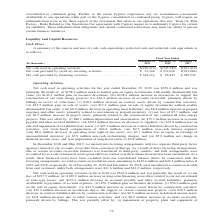From Sunpower Corporation's financial document, What are the components of the sources and uses of cash, cash equivalents, restricted cash and restricted cash equivalents? The document contains multiple relevant values: Operating activities, Investing activities, Financing activities. From the document: "Net cash used in operating activities . $(270,413) $(543,389) $(267,412) Net cash provided by (used in) investing activities. . $ 21,366 21,366 $ 274,..." Also, What was the net cash provided by investing activities in 2017? According to the financial document, (293,084). The relevant text states: "d in) investing activities. . $ 21,366 $ 274,900 $(293,084) Net cash provided by financing activities . $ 344,314 $ 85,847 $ 589,932..." Also, What was the reason for the title of certain accounts receivable balances being transferred to third-party vendors? Factoring arrangements with two separate third-party factor agencies related to our accounts receivable from customers in Europe. The document states: "In December 2018 and May 2019, we entered into factoring arrangements with two separate third-party factor agencies related to our accounts receivable..." Additionally, Which year was the net cash used in operating activities the highest? According to the financial document, 2018. The relevant text states: "(In thousands) December 29, 2019 December 30, 2018 December 31, 2017..." Also, can you calculate: What was the change in net cash provided by investing activities from 2018 to 2019? Based on the calculation: $21,366 - $274,900 , the result is -253534 (in thousands). This is based on the information: "h provided by (used in) investing activities. . $ 21,366 $ 274,900 $(293,084) Net cash provided by financing activities . $ 344,314 $ 85,847 $ 589,932 d by (used in) investing activities. . $ 21,366 $..." The key data points involved are: 21,366, 274,900. Also, can you calculate: What is the percentage change of net cash provided by financing activities from 2017 to 2018? To answer this question, I need to perform calculations using the financial data. The calculation is: ($85,847 - $589,932)/$589,932 , which equals -85.45 (percentage). This is based on the information: "ed by financing activities . $ 344,314 $ 85,847 $ 589,932 sh provided by financing activities . $ 344,314 $ 85,847 $ 589,932..." The key data points involved are: 589,932, 85,847. 